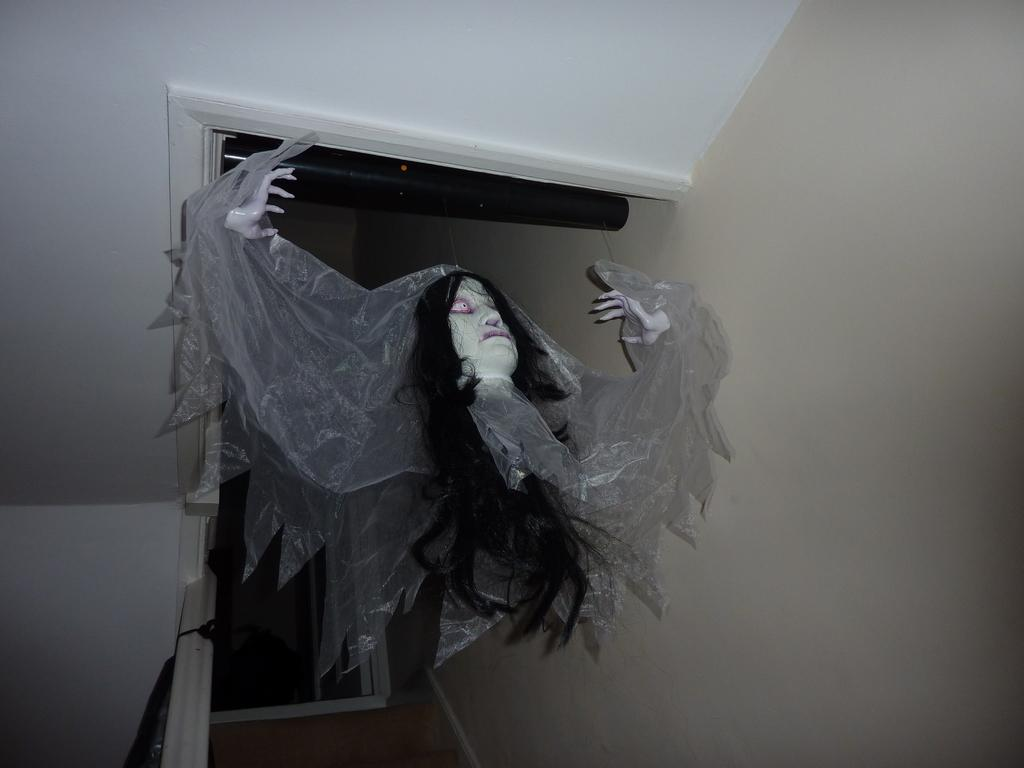What is the main subject in the center of the image? There is a doll in the center of the image. What can be seen in the background of the image? There is a wall visible in the background of the image. What type of horn can be seen on the doll in the image? There is no horn present on the doll in the image. Is there any snow visible in the image? There is no snow present in the image; it features a doll and a wall. 